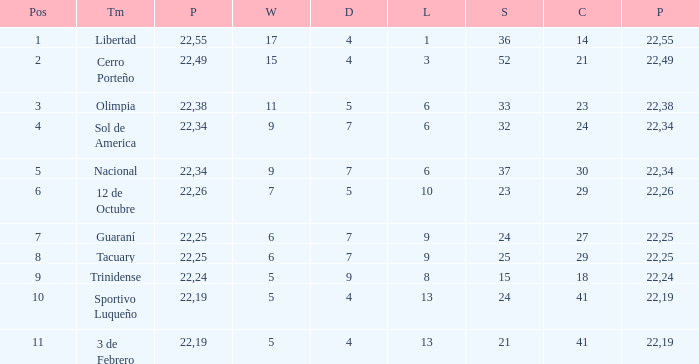What was the number of losses when the scored value was 25? 9.0. 